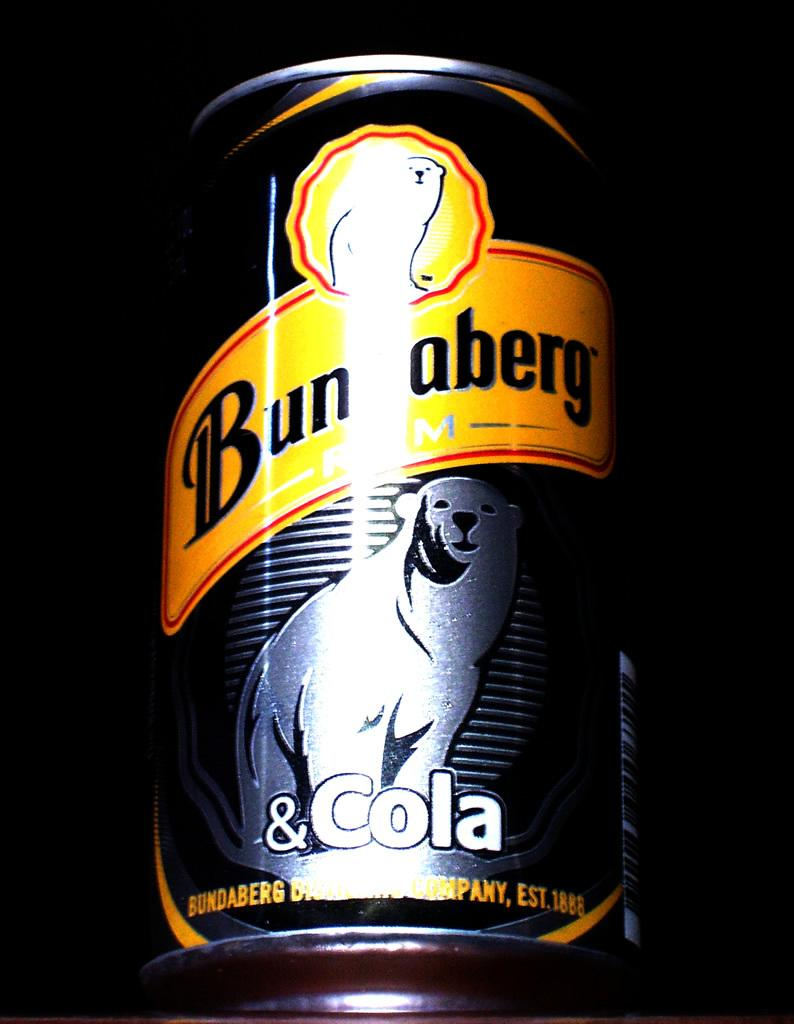<image>
Provide a brief description of the given image. a can that is labeled 'bundaberg rum & cola' 